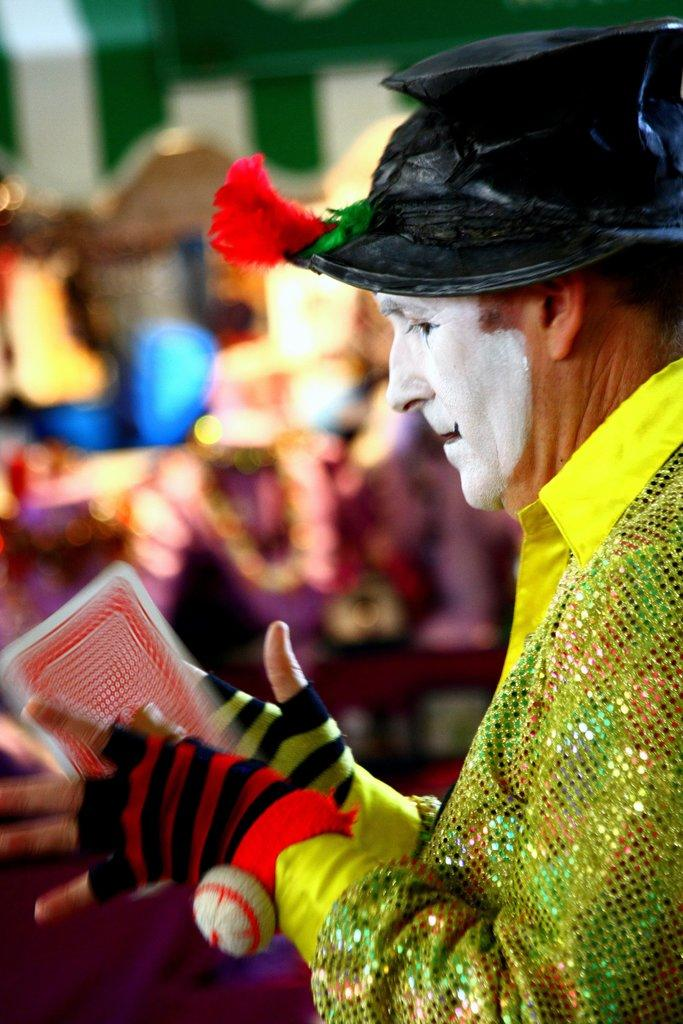What can be seen in the image? There is a person in the image. What is the person wearing? The person is wearing a yellow shirt. What is the person doing in the image? The person is standing and holding a card. Can you describe the background of the image? The background of the image is blurry. What type of butter is being used to hold the card in place in the image? There is no butter present in the image, and the card is being held by the person, not any type of butter. 